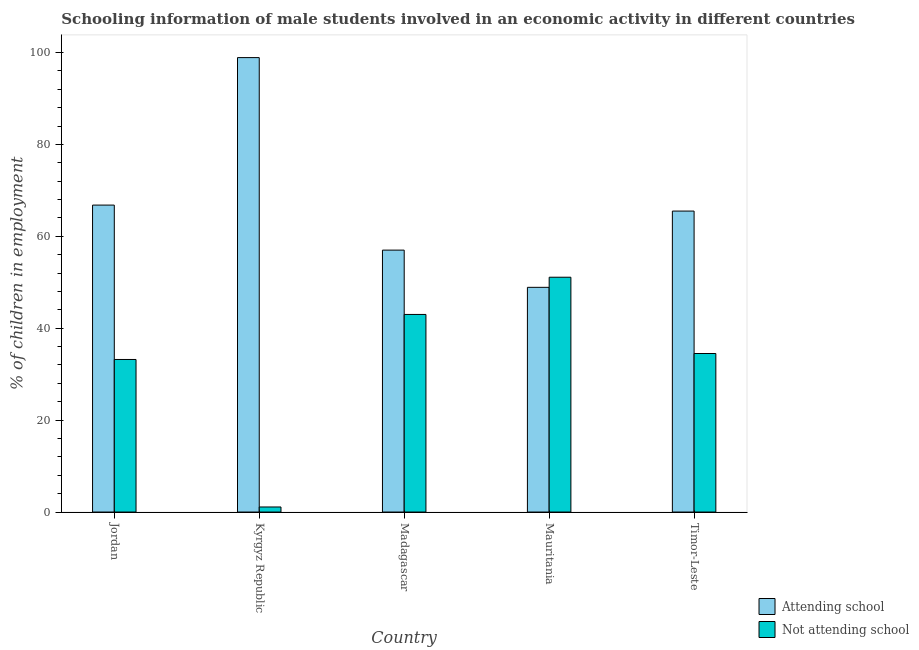How many groups of bars are there?
Offer a very short reply. 5. Are the number of bars on each tick of the X-axis equal?
Give a very brief answer. Yes. How many bars are there on the 3rd tick from the left?
Your answer should be very brief. 2. How many bars are there on the 5th tick from the right?
Your answer should be very brief. 2. What is the label of the 4th group of bars from the left?
Your answer should be very brief. Mauritania. In how many cases, is the number of bars for a given country not equal to the number of legend labels?
Offer a very short reply. 0. What is the percentage of employed males who are not attending school in Timor-Leste?
Your answer should be very brief. 34.5. Across all countries, what is the maximum percentage of employed males who are not attending school?
Provide a short and direct response. 51.1. In which country was the percentage of employed males who are attending school maximum?
Your answer should be very brief. Kyrgyz Republic. In which country was the percentage of employed males who are not attending school minimum?
Make the answer very short. Kyrgyz Republic. What is the total percentage of employed males who are attending school in the graph?
Make the answer very short. 337.1. What is the difference between the percentage of employed males who are not attending school in Kyrgyz Republic and that in Timor-Leste?
Offer a terse response. -33.4. What is the difference between the percentage of employed males who are attending school in Timor-Leste and the percentage of employed males who are not attending school in Madagascar?
Make the answer very short. 22.5. What is the average percentage of employed males who are not attending school per country?
Offer a terse response. 32.58. What is the difference between the percentage of employed males who are attending school and percentage of employed males who are not attending school in Jordan?
Provide a short and direct response. 33.6. In how many countries, is the percentage of employed males who are not attending school greater than 76 %?
Ensure brevity in your answer.  0. What is the ratio of the percentage of employed males who are attending school in Madagascar to that in Mauritania?
Make the answer very short. 1.17. What is the difference between the highest and the second highest percentage of employed males who are not attending school?
Keep it short and to the point. 8.1. What is the difference between the highest and the lowest percentage of employed males who are attending school?
Provide a short and direct response. 50. In how many countries, is the percentage of employed males who are not attending school greater than the average percentage of employed males who are not attending school taken over all countries?
Provide a succinct answer. 4. What does the 2nd bar from the left in Mauritania represents?
Offer a very short reply. Not attending school. What does the 1st bar from the right in Jordan represents?
Make the answer very short. Not attending school. What is the title of the graph?
Offer a terse response. Schooling information of male students involved in an economic activity in different countries. Does "Travel Items" appear as one of the legend labels in the graph?
Provide a short and direct response. No. What is the label or title of the X-axis?
Make the answer very short. Country. What is the label or title of the Y-axis?
Provide a succinct answer. % of children in employment. What is the % of children in employment in Attending school in Jordan?
Your response must be concise. 66.8. What is the % of children in employment in Not attending school in Jordan?
Your answer should be very brief. 33.2. What is the % of children in employment in Attending school in Kyrgyz Republic?
Keep it short and to the point. 98.9. What is the % of children in employment of Not attending school in Kyrgyz Republic?
Your answer should be very brief. 1.1. What is the % of children in employment in Attending school in Madagascar?
Your response must be concise. 57. What is the % of children in employment of Attending school in Mauritania?
Make the answer very short. 48.9. What is the % of children in employment of Not attending school in Mauritania?
Keep it short and to the point. 51.1. What is the % of children in employment in Attending school in Timor-Leste?
Provide a short and direct response. 65.5. What is the % of children in employment in Not attending school in Timor-Leste?
Your response must be concise. 34.5. Across all countries, what is the maximum % of children in employment in Attending school?
Your answer should be very brief. 98.9. Across all countries, what is the maximum % of children in employment of Not attending school?
Your response must be concise. 51.1. Across all countries, what is the minimum % of children in employment in Attending school?
Keep it short and to the point. 48.9. Across all countries, what is the minimum % of children in employment of Not attending school?
Keep it short and to the point. 1.1. What is the total % of children in employment of Attending school in the graph?
Ensure brevity in your answer.  337.1. What is the total % of children in employment in Not attending school in the graph?
Offer a terse response. 162.9. What is the difference between the % of children in employment of Attending school in Jordan and that in Kyrgyz Republic?
Ensure brevity in your answer.  -32.1. What is the difference between the % of children in employment of Not attending school in Jordan and that in Kyrgyz Republic?
Offer a very short reply. 32.1. What is the difference between the % of children in employment of Not attending school in Jordan and that in Mauritania?
Give a very brief answer. -17.9. What is the difference between the % of children in employment in Attending school in Kyrgyz Republic and that in Madagascar?
Your response must be concise. 41.9. What is the difference between the % of children in employment in Not attending school in Kyrgyz Republic and that in Madagascar?
Keep it short and to the point. -41.9. What is the difference between the % of children in employment in Attending school in Kyrgyz Republic and that in Mauritania?
Give a very brief answer. 50. What is the difference between the % of children in employment of Not attending school in Kyrgyz Republic and that in Mauritania?
Make the answer very short. -50. What is the difference between the % of children in employment in Attending school in Kyrgyz Republic and that in Timor-Leste?
Provide a short and direct response. 33.4. What is the difference between the % of children in employment in Not attending school in Kyrgyz Republic and that in Timor-Leste?
Your response must be concise. -33.4. What is the difference between the % of children in employment in Not attending school in Madagascar and that in Mauritania?
Your response must be concise. -8.1. What is the difference between the % of children in employment of Not attending school in Madagascar and that in Timor-Leste?
Your response must be concise. 8.5. What is the difference between the % of children in employment of Attending school in Mauritania and that in Timor-Leste?
Your answer should be compact. -16.6. What is the difference between the % of children in employment of Not attending school in Mauritania and that in Timor-Leste?
Your response must be concise. 16.6. What is the difference between the % of children in employment in Attending school in Jordan and the % of children in employment in Not attending school in Kyrgyz Republic?
Your answer should be very brief. 65.7. What is the difference between the % of children in employment in Attending school in Jordan and the % of children in employment in Not attending school in Madagascar?
Offer a terse response. 23.8. What is the difference between the % of children in employment of Attending school in Jordan and the % of children in employment of Not attending school in Timor-Leste?
Make the answer very short. 32.3. What is the difference between the % of children in employment in Attending school in Kyrgyz Republic and the % of children in employment in Not attending school in Madagascar?
Offer a very short reply. 55.9. What is the difference between the % of children in employment in Attending school in Kyrgyz Republic and the % of children in employment in Not attending school in Mauritania?
Provide a short and direct response. 47.8. What is the difference between the % of children in employment in Attending school in Kyrgyz Republic and the % of children in employment in Not attending school in Timor-Leste?
Give a very brief answer. 64.4. What is the difference between the % of children in employment in Attending school in Madagascar and the % of children in employment in Not attending school in Mauritania?
Make the answer very short. 5.9. What is the difference between the % of children in employment of Attending school in Mauritania and the % of children in employment of Not attending school in Timor-Leste?
Offer a very short reply. 14.4. What is the average % of children in employment of Attending school per country?
Offer a terse response. 67.42. What is the average % of children in employment in Not attending school per country?
Offer a terse response. 32.58. What is the difference between the % of children in employment of Attending school and % of children in employment of Not attending school in Jordan?
Keep it short and to the point. 33.6. What is the difference between the % of children in employment of Attending school and % of children in employment of Not attending school in Kyrgyz Republic?
Provide a succinct answer. 97.8. What is the difference between the % of children in employment of Attending school and % of children in employment of Not attending school in Madagascar?
Your answer should be very brief. 14. What is the difference between the % of children in employment in Attending school and % of children in employment in Not attending school in Mauritania?
Provide a succinct answer. -2.2. What is the difference between the % of children in employment in Attending school and % of children in employment in Not attending school in Timor-Leste?
Give a very brief answer. 31. What is the ratio of the % of children in employment of Attending school in Jordan to that in Kyrgyz Republic?
Your answer should be compact. 0.68. What is the ratio of the % of children in employment of Not attending school in Jordan to that in Kyrgyz Republic?
Make the answer very short. 30.18. What is the ratio of the % of children in employment of Attending school in Jordan to that in Madagascar?
Provide a short and direct response. 1.17. What is the ratio of the % of children in employment of Not attending school in Jordan to that in Madagascar?
Offer a very short reply. 0.77. What is the ratio of the % of children in employment in Attending school in Jordan to that in Mauritania?
Your response must be concise. 1.37. What is the ratio of the % of children in employment of Not attending school in Jordan to that in Mauritania?
Make the answer very short. 0.65. What is the ratio of the % of children in employment of Attending school in Jordan to that in Timor-Leste?
Your response must be concise. 1.02. What is the ratio of the % of children in employment in Not attending school in Jordan to that in Timor-Leste?
Ensure brevity in your answer.  0.96. What is the ratio of the % of children in employment in Attending school in Kyrgyz Republic to that in Madagascar?
Your response must be concise. 1.74. What is the ratio of the % of children in employment in Not attending school in Kyrgyz Republic to that in Madagascar?
Provide a succinct answer. 0.03. What is the ratio of the % of children in employment in Attending school in Kyrgyz Republic to that in Mauritania?
Your answer should be very brief. 2.02. What is the ratio of the % of children in employment in Not attending school in Kyrgyz Republic to that in Mauritania?
Give a very brief answer. 0.02. What is the ratio of the % of children in employment in Attending school in Kyrgyz Republic to that in Timor-Leste?
Keep it short and to the point. 1.51. What is the ratio of the % of children in employment of Not attending school in Kyrgyz Republic to that in Timor-Leste?
Offer a terse response. 0.03. What is the ratio of the % of children in employment of Attending school in Madagascar to that in Mauritania?
Your response must be concise. 1.17. What is the ratio of the % of children in employment in Not attending school in Madagascar to that in Mauritania?
Offer a very short reply. 0.84. What is the ratio of the % of children in employment in Attending school in Madagascar to that in Timor-Leste?
Provide a short and direct response. 0.87. What is the ratio of the % of children in employment of Not attending school in Madagascar to that in Timor-Leste?
Your response must be concise. 1.25. What is the ratio of the % of children in employment in Attending school in Mauritania to that in Timor-Leste?
Your answer should be very brief. 0.75. What is the ratio of the % of children in employment in Not attending school in Mauritania to that in Timor-Leste?
Offer a very short reply. 1.48. What is the difference between the highest and the second highest % of children in employment in Attending school?
Provide a succinct answer. 32.1. What is the difference between the highest and the second highest % of children in employment of Not attending school?
Your answer should be very brief. 8.1. What is the difference between the highest and the lowest % of children in employment in Attending school?
Your response must be concise. 50. What is the difference between the highest and the lowest % of children in employment in Not attending school?
Provide a short and direct response. 50. 